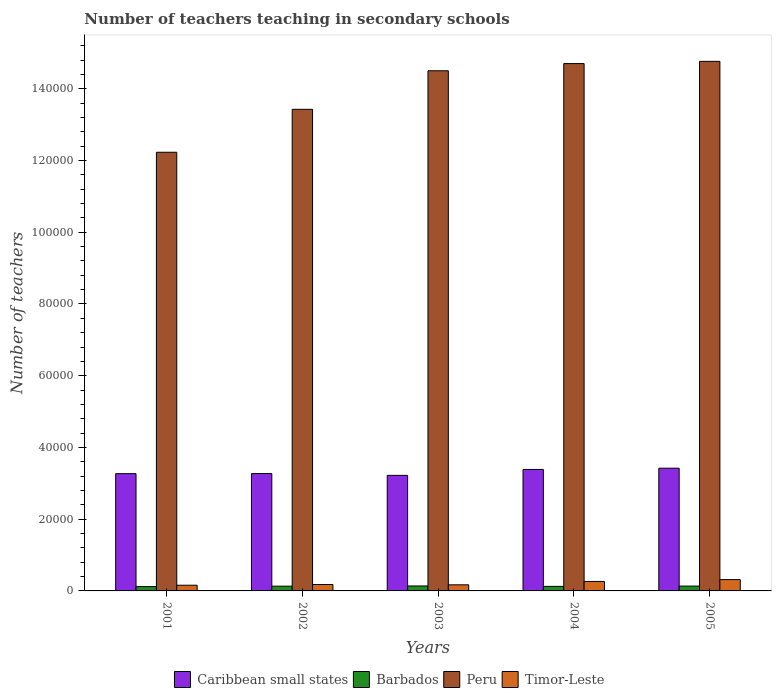How many groups of bars are there?
Ensure brevity in your answer.  5. How many bars are there on the 2nd tick from the right?
Your response must be concise. 4. What is the number of teachers teaching in secondary schools in Barbados in 2005?
Your response must be concise. 1348. Across all years, what is the maximum number of teachers teaching in secondary schools in Timor-Leste?
Provide a short and direct response. 3160. Across all years, what is the minimum number of teachers teaching in secondary schools in Timor-Leste?
Your response must be concise. 1589. In which year was the number of teachers teaching in secondary schools in Caribbean small states minimum?
Your response must be concise. 2003. What is the total number of teachers teaching in secondary schools in Barbados in the graph?
Your answer should be compact. 6529. What is the difference between the number of teachers teaching in secondary schools in Timor-Leste in 2001 and that in 2003?
Offer a terse response. -111. What is the difference between the number of teachers teaching in secondary schools in Caribbean small states in 2001 and the number of teachers teaching in secondary schools in Barbados in 2002?
Give a very brief answer. 3.14e+04. What is the average number of teachers teaching in secondary schools in Timor-Leste per year?
Your response must be concise. 2176. In the year 2001, what is the difference between the number of teachers teaching in secondary schools in Barbados and number of teachers teaching in secondary schools in Peru?
Your answer should be compact. -1.21e+05. In how many years, is the number of teachers teaching in secondary schools in Barbados greater than 60000?
Your answer should be very brief. 0. What is the ratio of the number of teachers teaching in secondary schools in Peru in 2002 to that in 2004?
Your answer should be very brief. 0.91. Is the number of teachers teaching in secondary schools in Timor-Leste in 2001 less than that in 2005?
Give a very brief answer. Yes. Is the difference between the number of teachers teaching in secondary schools in Barbados in 2001 and 2004 greater than the difference between the number of teachers teaching in secondary schools in Peru in 2001 and 2004?
Your response must be concise. Yes. What is the difference between the highest and the second highest number of teachers teaching in secondary schools in Peru?
Give a very brief answer. 621. What is the difference between the highest and the lowest number of teachers teaching in secondary schools in Peru?
Your response must be concise. 2.53e+04. Is it the case that in every year, the sum of the number of teachers teaching in secondary schools in Timor-Leste and number of teachers teaching in secondary schools in Peru is greater than the sum of number of teachers teaching in secondary schools in Caribbean small states and number of teachers teaching in secondary schools in Barbados?
Give a very brief answer. No. What does the 1st bar from the left in 2005 represents?
Ensure brevity in your answer.  Caribbean small states. What does the 4th bar from the right in 2001 represents?
Provide a short and direct response. Caribbean small states. Are all the bars in the graph horizontal?
Give a very brief answer. No. How many years are there in the graph?
Offer a terse response. 5. What is the difference between two consecutive major ticks on the Y-axis?
Provide a succinct answer. 2.00e+04. Does the graph contain grids?
Your response must be concise. No. Where does the legend appear in the graph?
Your answer should be compact. Bottom center. What is the title of the graph?
Make the answer very short. Number of teachers teaching in secondary schools. What is the label or title of the Y-axis?
Offer a very short reply. Number of teachers. What is the Number of teachers of Caribbean small states in 2001?
Ensure brevity in your answer.  3.27e+04. What is the Number of teachers in Barbados in 2001?
Make the answer very short. 1210. What is the Number of teachers in Peru in 2001?
Your response must be concise. 1.22e+05. What is the Number of teachers in Timor-Leste in 2001?
Offer a terse response. 1589. What is the Number of teachers of Caribbean small states in 2002?
Your answer should be compact. 3.27e+04. What is the Number of teachers of Barbados in 2002?
Keep it short and to the point. 1326. What is the Number of teachers of Peru in 2002?
Your answer should be compact. 1.34e+05. What is the Number of teachers in Timor-Leste in 2002?
Keep it short and to the point. 1787. What is the Number of teachers in Caribbean small states in 2003?
Your answer should be compact. 3.22e+04. What is the Number of teachers in Barbados in 2003?
Give a very brief answer. 1381. What is the Number of teachers in Peru in 2003?
Offer a very short reply. 1.45e+05. What is the Number of teachers in Timor-Leste in 2003?
Provide a succinct answer. 1700. What is the Number of teachers in Caribbean small states in 2004?
Keep it short and to the point. 3.39e+04. What is the Number of teachers of Barbados in 2004?
Make the answer very short. 1264. What is the Number of teachers of Peru in 2004?
Offer a terse response. 1.47e+05. What is the Number of teachers of Timor-Leste in 2004?
Keep it short and to the point. 2644. What is the Number of teachers of Caribbean small states in 2005?
Offer a very short reply. 3.42e+04. What is the Number of teachers in Barbados in 2005?
Give a very brief answer. 1348. What is the Number of teachers in Peru in 2005?
Your response must be concise. 1.48e+05. What is the Number of teachers of Timor-Leste in 2005?
Your response must be concise. 3160. Across all years, what is the maximum Number of teachers in Caribbean small states?
Your answer should be very brief. 3.42e+04. Across all years, what is the maximum Number of teachers in Barbados?
Keep it short and to the point. 1381. Across all years, what is the maximum Number of teachers in Peru?
Provide a succinct answer. 1.48e+05. Across all years, what is the maximum Number of teachers of Timor-Leste?
Your answer should be compact. 3160. Across all years, what is the minimum Number of teachers in Caribbean small states?
Your answer should be compact. 3.22e+04. Across all years, what is the minimum Number of teachers in Barbados?
Provide a succinct answer. 1210. Across all years, what is the minimum Number of teachers of Peru?
Give a very brief answer. 1.22e+05. Across all years, what is the minimum Number of teachers of Timor-Leste?
Offer a terse response. 1589. What is the total Number of teachers in Caribbean small states in the graph?
Your response must be concise. 1.66e+05. What is the total Number of teachers in Barbados in the graph?
Provide a short and direct response. 6529. What is the total Number of teachers in Peru in the graph?
Provide a short and direct response. 6.96e+05. What is the total Number of teachers of Timor-Leste in the graph?
Offer a terse response. 1.09e+04. What is the difference between the Number of teachers in Caribbean small states in 2001 and that in 2002?
Provide a short and direct response. -25.73. What is the difference between the Number of teachers of Barbados in 2001 and that in 2002?
Your answer should be compact. -116. What is the difference between the Number of teachers of Peru in 2001 and that in 2002?
Offer a terse response. -1.20e+04. What is the difference between the Number of teachers of Timor-Leste in 2001 and that in 2002?
Provide a succinct answer. -198. What is the difference between the Number of teachers of Caribbean small states in 2001 and that in 2003?
Offer a very short reply. 474.77. What is the difference between the Number of teachers in Barbados in 2001 and that in 2003?
Offer a very short reply. -171. What is the difference between the Number of teachers of Peru in 2001 and that in 2003?
Ensure brevity in your answer.  -2.27e+04. What is the difference between the Number of teachers of Timor-Leste in 2001 and that in 2003?
Offer a very short reply. -111. What is the difference between the Number of teachers of Caribbean small states in 2001 and that in 2004?
Keep it short and to the point. -1174.84. What is the difference between the Number of teachers in Barbados in 2001 and that in 2004?
Give a very brief answer. -54. What is the difference between the Number of teachers in Peru in 2001 and that in 2004?
Your response must be concise. -2.47e+04. What is the difference between the Number of teachers of Timor-Leste in 2001 and that in 2004?
Offer a very short reply. -1055. What is the difference between the Number of teachers of Caribbean small states in 2001 and that in 2005?
Keep it short and to the point. -1525.32. What is the difference between the Number of teachers of Barbados in 2001 and that in 2005?
Offer a terse response. -138. What is the difference between the Number of teachers of Peru in 2001 and that in 2005?
Provide a short and direct response. -2.53e+04. What is the difference between the Number of teachers of Timor-Leste in 2001 and that in 2005?
Give a very brief answer. -1571. What is the difference between the Number of teachers of Caribbean small states in 2002 and that in 2003?
Keep it short and to the point. 500.5. What is the difference between the Number of teachers in Barbados in 2002 and that in 2003?
Offer a terse response. -55. What is the difference between the Number of teachers of Peru in 2002 and that in 2003?
Give a very brief answer. -1.08e+04. What is the difference between the Number of teachers in Caribbean small states in 2002 and that in 2004?
Keep it short and to the point. -1149.11. What is the difference between the Number of teachers in Barbados in 2002 and that in 2004?
Offer a very short reply. 62. What is the difference between the Number of teachers in Peru in 2002 and that in 2004?
Ensure brevity in your answer.  -1.28e+04. What is the difference between the Number of teachers of Timor-Leste in 2002 and that in 2004?
Provide a short and direct response. -857. What is the difference between the Number of teachers in Caribbean small states in 2002 and that in 2005?
Your answer should be very brief. -1499.58. What is the difference between the Number of teachers in Barbados in 2002 and that in 2005?
Your answer should be very brief. -22. What is the difference between the Number of teachers in Peru in 2002 and that in 2005?
Make the answer very short. -1.34e+04. What is the difference between the Number of teachers in Timor-Leste in 2002 and that in 2005?
Provide a succinct answer. -1373. What is the difference between the Number of teachers in Caribbean small states in 2003 and that in 2004?
Offer a terse response. -1649.61. What is the difference between the Number of teachers in Barbados in 2003 and that in 2004?
Keep it short and to the point. 117. What is the difference between the Number of teachers of Peru in 2003 and that in 2004?
Provide a short and direct response. -2001. What is the difference between the Number of teachers of Timor-Leste in 2003 and that in 2004?
Your response must be concise. -944. What is the difference between the Number of teachers of Caribbean small states in 2003 and that in 2005?
Your answer should be compact. -2000.08. What is the difference between the Number of teachers in Peru in 2003 and that in 2005?
Provide a succinct answer. -2622. What is the difference between the Number of teachers of Timor-Leste in 2003 and that in 2005?
Make the answer very short. -1460. What is the difference between the Number of teachers of Caribbean small states in 2004 and that in 2005?
Your answer should be compact. -350.48. What is the difference between the Number of teachers of Barbados in 2004 and that in 2005?
Provide a short and direct response. -84. What is the difference between the Number of teachers in Peru in 2004 and that in 2005?
Offer a terse response. -621. What is the difference between the Number of teachers in Timor-Leste in 2004 and that in 2005?
Offer a very short reply. -516. What is the difference between the Number of teachers of Caribbean small states in 2001 and the Number of teachers of Barbados in 2002?
Provide a short and direct response. 3.14e+04. What is the difference between the Number of teachers of Caribbean small states in 2001 and the Number of teachers of Peru in 2002?
Give a very brief answer. -1.02e+05. What is the difference between the Number of teachers in Caribbean small states in 2001 and the Number of teachers in Timor-Leste in 2002?
Keep it short and to the point. 3.09e+04. What is the difference between the Number of teachers of Barbados in 2001 and the Number of teachers of Peru in 2002?
Offer a terse response. -1.33e+05. What is the difference between the Number of teachers in Barbados in 2001 and the Number of teachers in Timor-Leste in 2002?
Give a very brief answer. -577. What is the difference between the Number of teachers in Peru in 2001 and the Number of teachers in Timor-Leste in 2002?
Ensure brevity in your answer.  1.21e+05. What is the difference between the Number of teachers of Caribbean small states in 2001 and the Number of teachers of Barbados in 2003?
Your response must be concise. 3.13e+04. What is the difference between the Number of teachers in Caribbean small states in 2001 and the Number of teachers in Peru in 2003?
Your answer should be very brief. -1.12e+05. What is the difference between the Number of teachers in Caribbean small states in 2001 and the Number of teachers in Timor-Leste in 2003?
Make the answer very short. 3.10e+04. What is the difference between the Number of teachers in Barbados in 2001 and the Number of teachers in Peru in 2003?
Provide a short and direct response. -1.44e+05. What is the difference between the Number of teachers in Barbados in 2001 and the Number of teachers in Timor-Leste in 2003?
Offer a terse response. -490. What is the difference between the Number of teachers in Peru in 2001 and the Number of teachers in Timor-Leste in 2003?
Offer a very short reply. 1.21e+05. What is the difference between the Number of teachers of Caribbean small states in 2001 and the Number of teachers of Barbados in 2004?
Offer a terse response. 3.14e+04. What is the difference between the Number of teachers of Caribbean small states in 2001 and the Number of teachers of Peru in 2004?
Provide a succinct answer. -1.14e+05. What is the difference between the Number of teachers of Caribbean small states in 2001 and the Number of teachers of Timor-Leste in 2004?
Make the answer very short. 3.00e+04. What is the difference between the Number of teachers of Barbados in 2001 and the Number of teachers of Peru in 2004?
Give a very brief answer. -1.46e+05. What is the difference between the Number of teachers of Barbados in 2001 and the Number of teachers of Timor-Leste in 2004?
Provide a short and direct response. -1434. What is the difference between the Number of teachers of Peru in 2001 and the Number of teachers of Timor-Leste in 2004?
Provide a succinct answer. 1.20e+05. What is the difference between the Number of teachers in Caribbean small states in 2001 and the Number of teachers in Barbados in 2005?
Make the answer very short. 3.13e+04. What is the difference between the Number of teachers of Caribbean small states in 2001 and the Number of teachers of Peru in 2005?
Keep it short and to the point. -1.15e+05. What is the difference between the Number of teachers of Caribbean small states in 2001 and the Number of teachers of Timor-Leste in 2005?
Make the answer very short. 2.95e+04. What is the difference between the Number of teachers of Barbados in 2001 and the Number of teachers of Peru in 2005?
Your response must be concise. -1.46e+05. What is the difference between the Number of teachers in Barbados in 2001 and the Number of teachers in Timor-Leste in 2005?
Keep it short and to the point. -1950. What is the difference between the Number of teachers in Peru in 2001 and the Number of teachers in Timor-Leste in 2005?
Offer a terse response. 1.19e+05. What is the difference between the Number of teachers in Caribbean small states in 2002 and the Number of teachers in Barbados in 2003?
Offer a very short reply. 3.13e+04. What is the difference between the Number of teachers in Caribbean small states in 2002 and the Number of teachers in Peru in 2003?
Give a very brief answer. -1.12e+05. What is the difference between the Number of teachers of Caribbean small states in 2002 and the Number of teachers of Timor-Leste in 2003?
Make the answer very short. 3.10e+04. What is the difference between the Number of teachers in Barbados in 2002 and the Number of teachers in Peru in 2003?
Provide a succinct answer. -1.44e+05. What is the difference between the Number of teachers in Barbados in 2002 and the Number of teachers in Timor-Leste in 2003?
Provide a succinct answer. -374. What is the difference between the Number of teachers of Peru in 2002 and the Number of teachers of Timor-Leste in 2003?
Your answer should be compact. 1.33e+05. What is the difference between the Number of teachers of Caribbean small states in 2002 and the Number of teachers of Barbados in 2004?
Keep it short and to the point. 3.15e+04. What is the difference between the Number of teachers in Caribbean small states in 2002 and the Number of teachers in Peru in 2004?
Offer a very short reply. -1.14e+05. What is the difference between the Number of teachers of Caribbean small states in 2002 and the Number of teachers of Timor-Leste in 2004?
Offer a terse response. 3.01e+04. What is the difference between the Number of teachers of Barbados in 2002 and the Number of teachers of Peru in 2004?
Your answer should be very brief. -1.46e+05. What is the difference between the Number of teachers of Barbados in 2002 and the Number of teachers of Timor-Leste in 2004?
Make the answer very short. -1318. What is the difference between the Number of teachers in Peru in 2002 and the Number of teachers in Timor-Leste in 2004?
Provide a short and direct response. 1.32e+05. What is the difference between the Number of teachers of Caribbean small states in 2002 and the Number of teachers of Barbados in 2005?
Your response must be concise. 3.14e+04. What is the difference between the Number of teachers of Caribbean small states in 2002 and the Number of teachers of Peru in 2005?
Your response must be concise. -1.15e+05. What is the difference between the Number of teachers in Caribbean small states in 2002 and the Number of teachers in Timor-Leste in 2005?
Give a very brief answer. 2.96e+04. What is the difference between the Number of teachers of Barbados in 2002 and the Number of teachers of Peru in 2005?
Offer a very short reply. -1.46e+05. What is the difference between the Number of teachers in Barbados in 2002 and the Number of teachers in Timor-Leste in 2005?
Your response must be concise. -1834. What is the difference between the Number of teachers in Peru in 2002 and the Number of teachers in Timor-Leste in 2005?
Provide a succinct answer. 1.31e+05. What is the difference between the Number of teachers in Caribbean small states in 2003 and the Number of teachers in Barbados in 2004?
Keep it short and to the point. 3.10e+04. What is the difference between the Number of teachers in Caribbean small states in 2003 and the Number of teachers in Peru in 2004?
Keep it short and to the point. -1.15e+05. What is the difference between the Number of teachers of Caribbean small states in 2003 and the Number of teachers of Timor-Leste in 2004?
Provide a short and direct response. 2.96e+04. What is the difference between the Number of teachers in Barbados in 2003 and the Number of teachers in Peru in 2004?
Provide a succinct answer. -1.46e+05. What is the difference between the Number of teachers of Barbados in 2003 and the Number of teachers of Timor-Leste in 2004?
Offer a terse response. -1263. What is the difference between the Number of teachers of Peru in 2003 and the Number of teachers of Timor-Leste in 2004?
Your response must be concise. 1.42e+05. What is the difference between the Number of teachers of Caribbean small states in 2003 and the Number of teachers of Barbados in 2005?
Provide a short and direct response. 3.09e+04. What is the difference between the Number of teachers of Caribbean small states in 2003 and the Number of teachers of Peru in 2005?
Your response must be concise. -1.15e+05. What is the difference between the Number of teachers in Caribbean small states in 2003 and the Number of teachers in Timor-Leste in 2005?
Keep it short and to the point. 2.91e+04. What is the difference between the Number of teachers of Barbados in 2003 and the Number of teachers of Peru in 2005?
Ensure brevity in your answer.  -1.46e+05. What is the difference between the Number of teachers in Barbados in 2003 and the Number of teachers in Timor-Leste in 2005?
Keep it short and to the point. -1779. What is the difference between the Number of teachers in Peru in 2003 and the Number of teachers in Timor-Leste in 2005?
Give a very brief answer. 1.42e+05. What is the difference between the Number of teachers in Caribbean small states in 2004 and the Number of teachers in Barbados in 2005?
Provide a short and direct response. 3.25e+04. What is the difference between the Number of teachers of Caribbean small states in 2004 and the Number of teachers of Peru in 2005?
Your response must be concise. -1.14e+05. What is the difference between the Number of teachers of Caribbean small states in 2004 and the Number of teachers of Timor-Leste in 2005?
Give a very brief answer. 3.07e+04. What is the difference between the Number of teachers in Barbados in 2004 and the Number of teachers in Peru in 2005?
Your answer should be compact. -1.46e+05. What is the difference between the Number of teachers in Barbados in 2004 and the Number of teachers in Timor-Leste in 2005?
Your answer should be very brief. -1896. What is the difference between the Number of teachers of Peru in 2004 and the Number of teachers of Timor-Leste in 2005?
Ensure brevity in your answer.  1.44e+05. What is the average Number of teachers in Caribbean small states per year?
Keep it short and to the point. 3.31e+04. What is the average Number of teachers of Barbados per year?
Make the answer very short. 1305.8. What is the average Number of teachers in Peru per year?
Provide a short and direct response. 1.39e+05. What is the average Number of teachers of Timor-Leste per year?
Your answer should be compact. 2176. In the year 2001, what is the difference between the Number of teachers in Caribbean small states and Number of teachers in Barbados?
Offer a very short reply. 3.15e+04. In the year 2001, what is the difference between the Number of teachers of Caribbean small states and Number of teachers of Peru?
Make the answer very short. -8.96e+04. In the year 2001, what is the difference between the Number of teachers in Caribbean small states and Number of teachers in Timor-Leste?
Your answer should be compact. 3.11e+04. In the year 2001, what is the difference between the Number of teachers of Barbados and Number of teachers of Peru?
Provide a short and direct response. -1.21e+05. In the year 2001, what is the difference between the Number of teachers in Barbados and Number of teachers in Timor-Leste?
Your answer should be very brief. -379. In the year 2001, what is the difference between the Number of teachers of Peru and Number of teachers of Timor-Leste?
Make the answer very short. 1.21e+05. In the year 2002, what is the difference between the Number of teachers in Caribbean small states and Number of teachers in Barbados?
Your response must be concise. 3.14e+04. In the year 2002, what is the difference between the Number of teachers of Caribbean small states and Number of teachers of Peru?
Provide a succinct answer. -1.02e+05. In the year 2002, what is the difference between the Number of teachers in Caribbean small states and Number of teachers in Timor-Leste?
Make the answer very short. 3.09e+04. In the year 2002, what is the difference between the Number of teachers in Barbados and Number of teachers in Peru?
Keep it short and to the point. -1.33e+05. In the year 2002, what is the difference between the Number of teachers in Barbados and Number of teachers in Timor-Leste?
Offer a terse response. -461. In the year 2002, what is the difference between the Number of teachers of Peru and Number of teachers of Timor-Leste?
Offer a very short reply. 1.32e+05. In the year 2003, what is the difference between the Number of teachers of Caribbean small states and Number of teachers of Barbados?
Offer a terse response. 3.08e+04. In the year 2003, what is the difference between the Number of teachers in Caribbean small states and Number of teachers in Peru?
Your response must be concise. -1.13e+05. In the year 2003, what is the difference between the Number of teachers in Caribbean small states and Number of teachers in Timor-Leste?
Ensure brevity in your answer.  3.05e+04. In the year 2003, what is the difference between the Number of teachers of Barbados and Number of teachers of Peru?
Offer a terse response. -1.44e+05. In the year 2003, what is the difference between the Number of teachers of Barbados and Number of teachers of Timor-Leste?
Provide a succinct answer. -319. In the year 2003, what is the difference between the Number of teachers of Peru and Number of teachers of Timor-Leste?
Ensure brevity in your answer.  1.43e+05. In the year 2004, what is the difference between the Number of teachers of Caribbean small states and Number of teachers of Barbados?
Ensure brevity in your answer.  3.26e+04. In the year 2004, what is the difference between the Number of teachers of Caribbean small states and Number of teachers of Peru?
Keep it short and to the point. -1.13e+05. In the year 2004, what is the difference between the Number of teachers of Caribbean small states and Number of teachers of Timor-Leste?
Your answer should be compact. 3.12e+04. In the year 2004, what is the difference between the Number of teachers of Barbados and Number of teachers of Peru?
Offer a very short reply. -1.46e+05. In the year 2004, what is the difference between the Number of teachers in Barbados and Number of teachers in Timor-Leste?
Provide a succinct answer. -1380. In the year 2004, what is the difference between the Number of teachers of Peru and Number of teachers of Timor-Leste?
Offer a terse response. 1.44e+05. In the year 2005, what is the difference between the Number of teachers of Caribbean small states and Number of teachers of Barbados?
Your answer should be very brief. 3.29e+04. In the year 2005, what is the difference between the Number of teachers in Caribbean small states and Number of teachers in Peru?
Offer a terse response. -1.13e+05. In the year 2005, what is the difference between the Number of teachers of Caribbean small states and Number of teachers of Timor-Leste?
Ensure brevity in your answer.  3.11e+04. In the year 2005, what is the difference between the Number of teachers in Barbados and Number of teachers in Peru?
Provide a short and direct response. -1.46e+05. In the year 2005, what is the difference between the Number of teachers in Barbados and Number of teachers in Timor-Leste?
Your answer should be compact. -1812. In the year 2005, what is the difference between the Number of teachers of Peru and Number of teachers of Timor-Leste?
Your response must be concise. 1.44e+05. What is the ratio of the Number of teachers in Barbados in 2001 to that in 2002?
Your answer should be compact. 0.91. What is the ratio of the Number of teachers in Peru in 2001 to that in 2002?
Ensure brevity in your answer.  0.91. What is the ratio of the Number of teachers in Timor-Leste in 2001 to that in 2002?
Offer a terse response. 0.89. What is the ratio of the Number of teachers in Caribbean small states in 2001 to that in 2003?
Ensure brevity in your answer.  1.01. What is the ratio of the Number of teachers in Barbados in 2001 to that in 2003?
Ensure brevity in your answer.  0.88. What is the ratio of the Number of teachers in Peru in 2001 to that in 2003?
Keep it short and to the point. 0.84. What is the ratio of the Number of teachers of Timor-Leste in 2001 to that in 2003?
Provide a short and direct response. 0.93. What is the ratio of the Number of teachers of Caribbean small states in 2001 to that in 2004?
Provide a succinct answer. 0.97. What is the ratio of the Number of teachers in Barbados in 2001 to that in 2004?
Make the answer very short. 0.96. What is the ratio of the Number of teachers in Peru in 2001 to that in 2004?
Your response must be concise. 0.83. What is the ratio of the Number of teachers in Timor-Leste in 2001 to that in 2004?
Offer a very short reply. 0.6. What is the ratio of the Number of teachers of Caribbean small states in 2001 to that in 2005?
Your answer should be compact. 0.96. What is the ratio of the Number of teachers in Barbados in 2001 to that in 2005?
Ensure brevity in your answer.  0.9. What is the ratio of the Number of teachers of Peru in 2001 to that in 2005?
Make the answer very short. 0.83. What is the ratio of the Number of teachers in Timor-Leste in 2001 to that in 2005?
Provide a short and direct response. 0.5. What is the ratio of the Number of teachers in Caribbean small states in 2002 to that in 2003?
Provide a succinct answer. 1.02. What is the ratio of the Number of teachers in Barbados in 2002 to that in 2003?
Offer a very short reply. 0.96. What is the ratio of the Number of teachers in Peru in 2002 to that in 2003?
Offer a terse response. 0.93. What is the ratio of the Number of teachers of Timor-Leste in 2002 to that in 2003?
Give a very brief answer. 1.05. What is the ratio of the Number of teachers in Caribbean small states in 2002 to that in 2004?
Offer a terse response. 0.97. What is the ratio of the Number of teachers in Barbados in 2002 to that in 2004?
Provide a short and direct response. 1.05. What is the ratio of the Number of teachers in Peru in 2002 to that in 2004?
Your answer should be compact. 0.91. What is the ratio of the Number of teachers of Timor-Leste in 2002 to that in 2004?
Provide a succinct answer. 0.68. What is the ratio of the Number of teachers of Caribbean small states in 2002 to that in 2005?
Offer a very short reply. 0.96. What is the ratio of the Number of teachers of Barbados in 2002 to that in 2005?
Provide a succinct answer. 0.98. What is the ratio of the Number of teachers in Peru in 2002 to that in 2005?
Ensure brevity in your answer.  0.91. What is the ratio of the Number of teachers of Timor-Leste in 2002 to that in 2005?
Ensure brevity in your answer.  0.57. What is the ratio of the Number of teachers in Caribbean small states in 2003 to that in 2004?
Make the answer very short. 0.95. What is the ratio of the Number of teachers of Barbados in 2003 to that in 2004?
Your response must be concise. 1.09. What is the ratio of the Number of teachers in Peru in 2003 to that in 2004?
Give a very brief answer. 0.99. What is the ratio of the Number of teachers in Timor-Leste in 2003 to that in 2004?
Ensure brevity in your answer.  0.64. What is the ratio of the Number of teachers of Caribbean small states in 2003 to that in 2005?
Offer a terse response. 0.94. What is the ratio of the Number of teachers in Barbados in 2003 to that in 2005?
Make the answer very short. 1.02. What is the ratio of the Number of teachers of Peru in 2003 to that in 2005?
Your answer should be compact. 0.98. What is the ratio of the Number of teachers of Timor-Leste in 2003 to that in 2005?
Offer a very short reply. 0.54. What is the ratio of the Number of teachers of Barbados in 2004 to that in 2005?
Provide a short and direct response. 0.94. What is the ratio of the Number of teachers of Timor-Leste in 2004 to that in 2005?
Offer a very short reply. 0.84. What is the difference between the highest and the second highest Number of teachers of Caribbean small states?
Your response must be concise. 350.48. What is the difference between the highest and the second highest Number of teachers of Barbados?
Your answer should be very brief. 33. What is the difference between the highest and the second highest Number of teachers in Peru?
Your answer should be very brief. 621. What is the difference between the highest and the second highest Number of teachers in Timor-Leste?
Give a very brief answer. 516. What is the difference between the highest and the lowest Number of teachers of Caribbean small states?
Your answer should be compact. 2000.08. What is the difference between the highest and the lowest Number of teachers of Barbados?
Offer a terse response. 171. What is the difference between the highest and the lowest Number of teachers of Peru?
Provide a short and direct response. 2.53e+04. What is the difference between the highest and the lowest Number of teachers in Timor-Leste?
Give a very brief answer. 1571. 